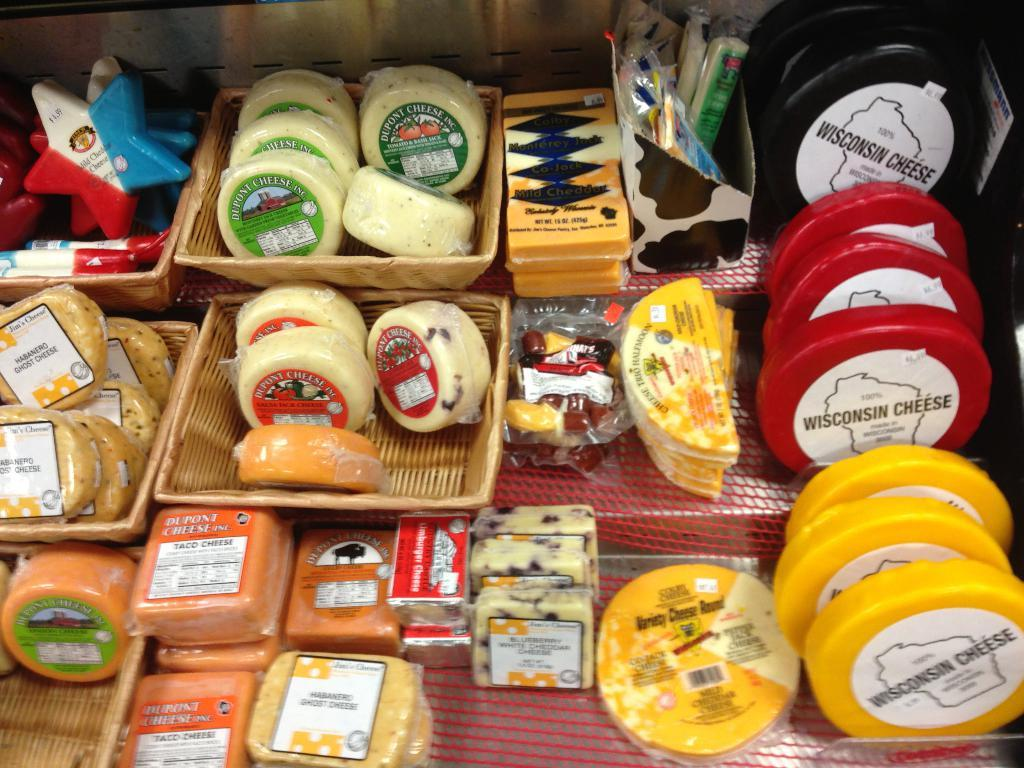<image>
Present a compact description of the photo's key features. A selection of cheese including Wisconsin cheese at the top left. 